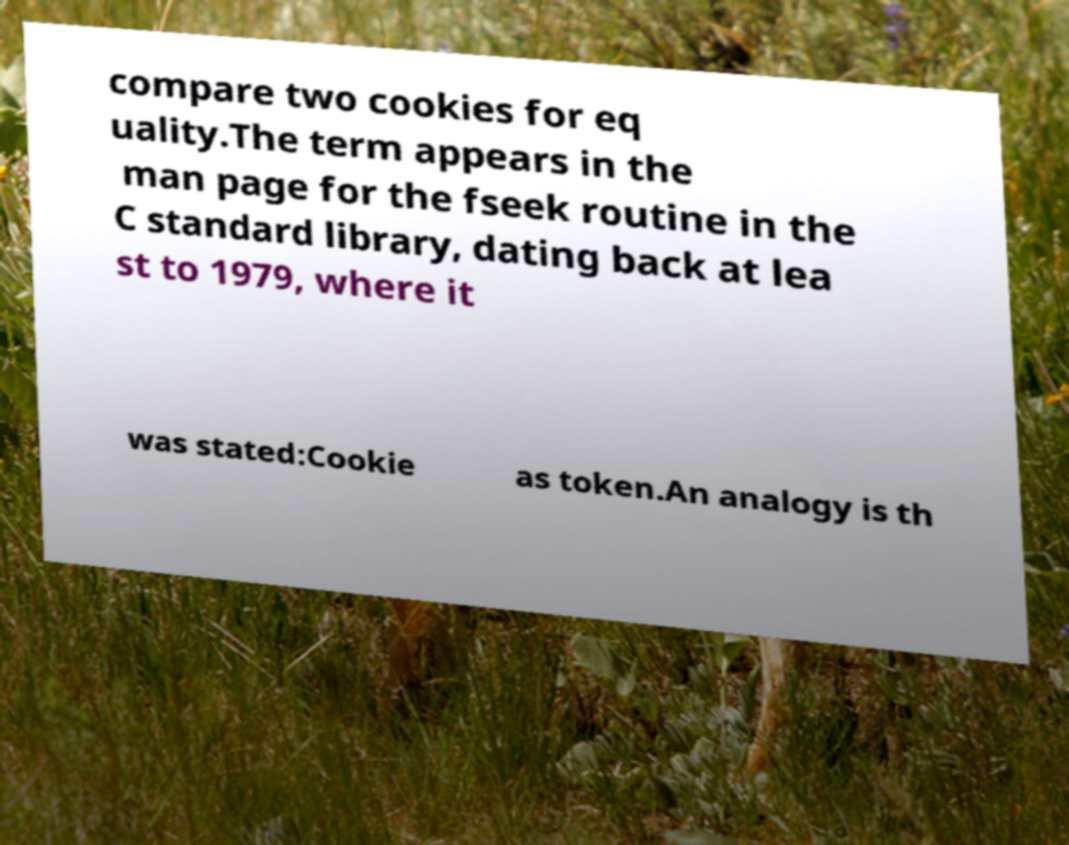Can you accurately transcribe the text from the provided image for me? compare two cookies for eq uality.The term appears in the man page for the fseek routine in the C standard library, dating back at lea st to 1979, where it was stated:Cookie as token.An analogy is th 